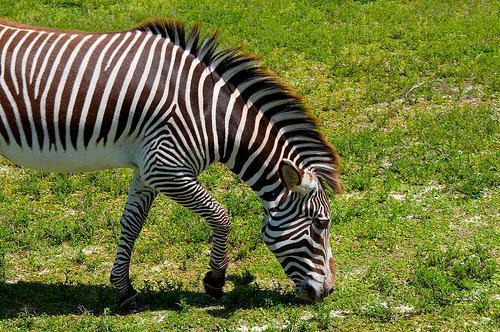How many zebras are visible?
Give a very brief answer. 1. How many zebras are there?
Give a very brief answer. 1. How many colors are shown?
Give a very brief answer. 3. How many zebras are in the field?
Give a very brief answer. 1. 